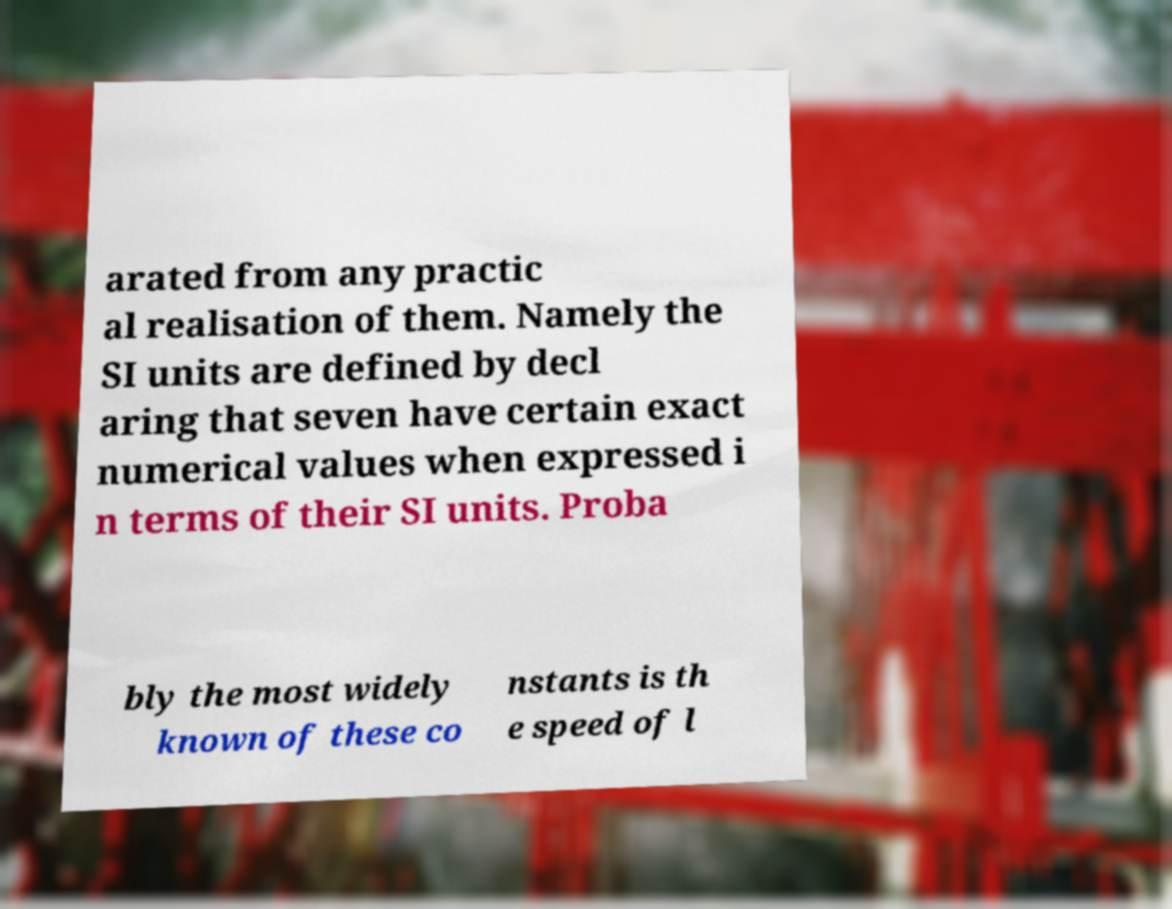There's text embedded in this image that I need extracted. Can you transcribe it verbatim? arated from any practic al realisation of them. Namely the SI units are defined by decl aring that seven have certain exact numerical values when expressed i n terms of their SI units. Proba bly the most widely known of these co nstants is th e speed of l 